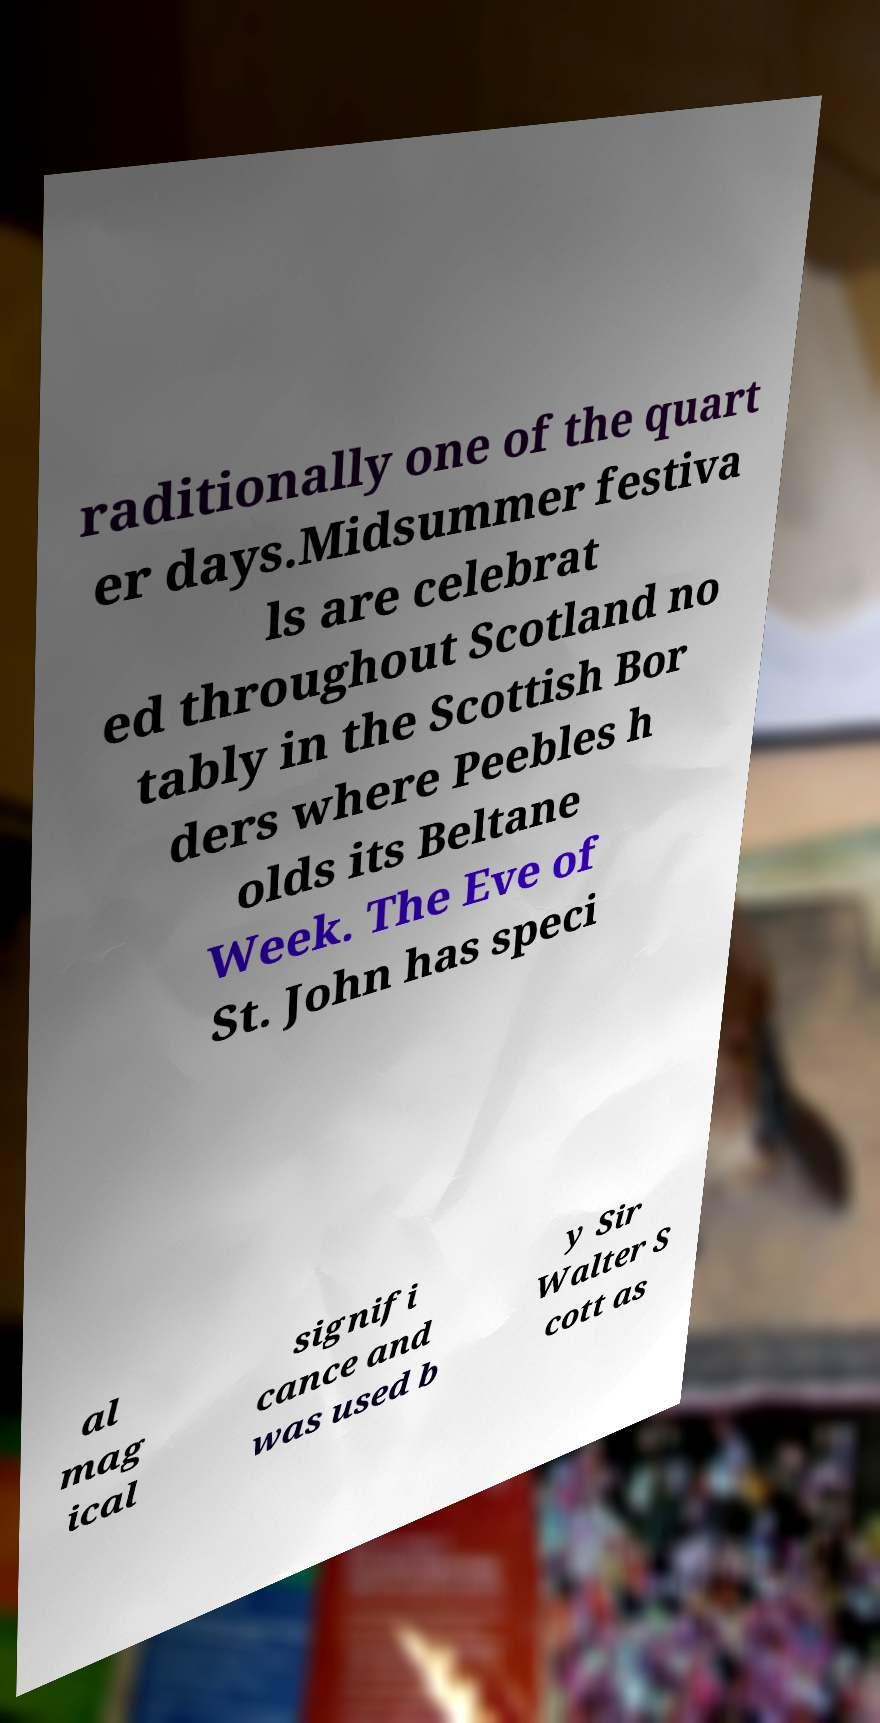Can you read and provide the text displayed in the image?This photo seems to have some interesting text. Can you extract and type it out for me? raditionally one of the quart er days.Midsummer festiva ls are celebrat ed throughout Scotland no tably in the Scottish Bor ders where Peebles h olds its Beltane Week. The Eve of St. John has speci al mag ical signifi cance and was used b y Sir Walter S cott as 